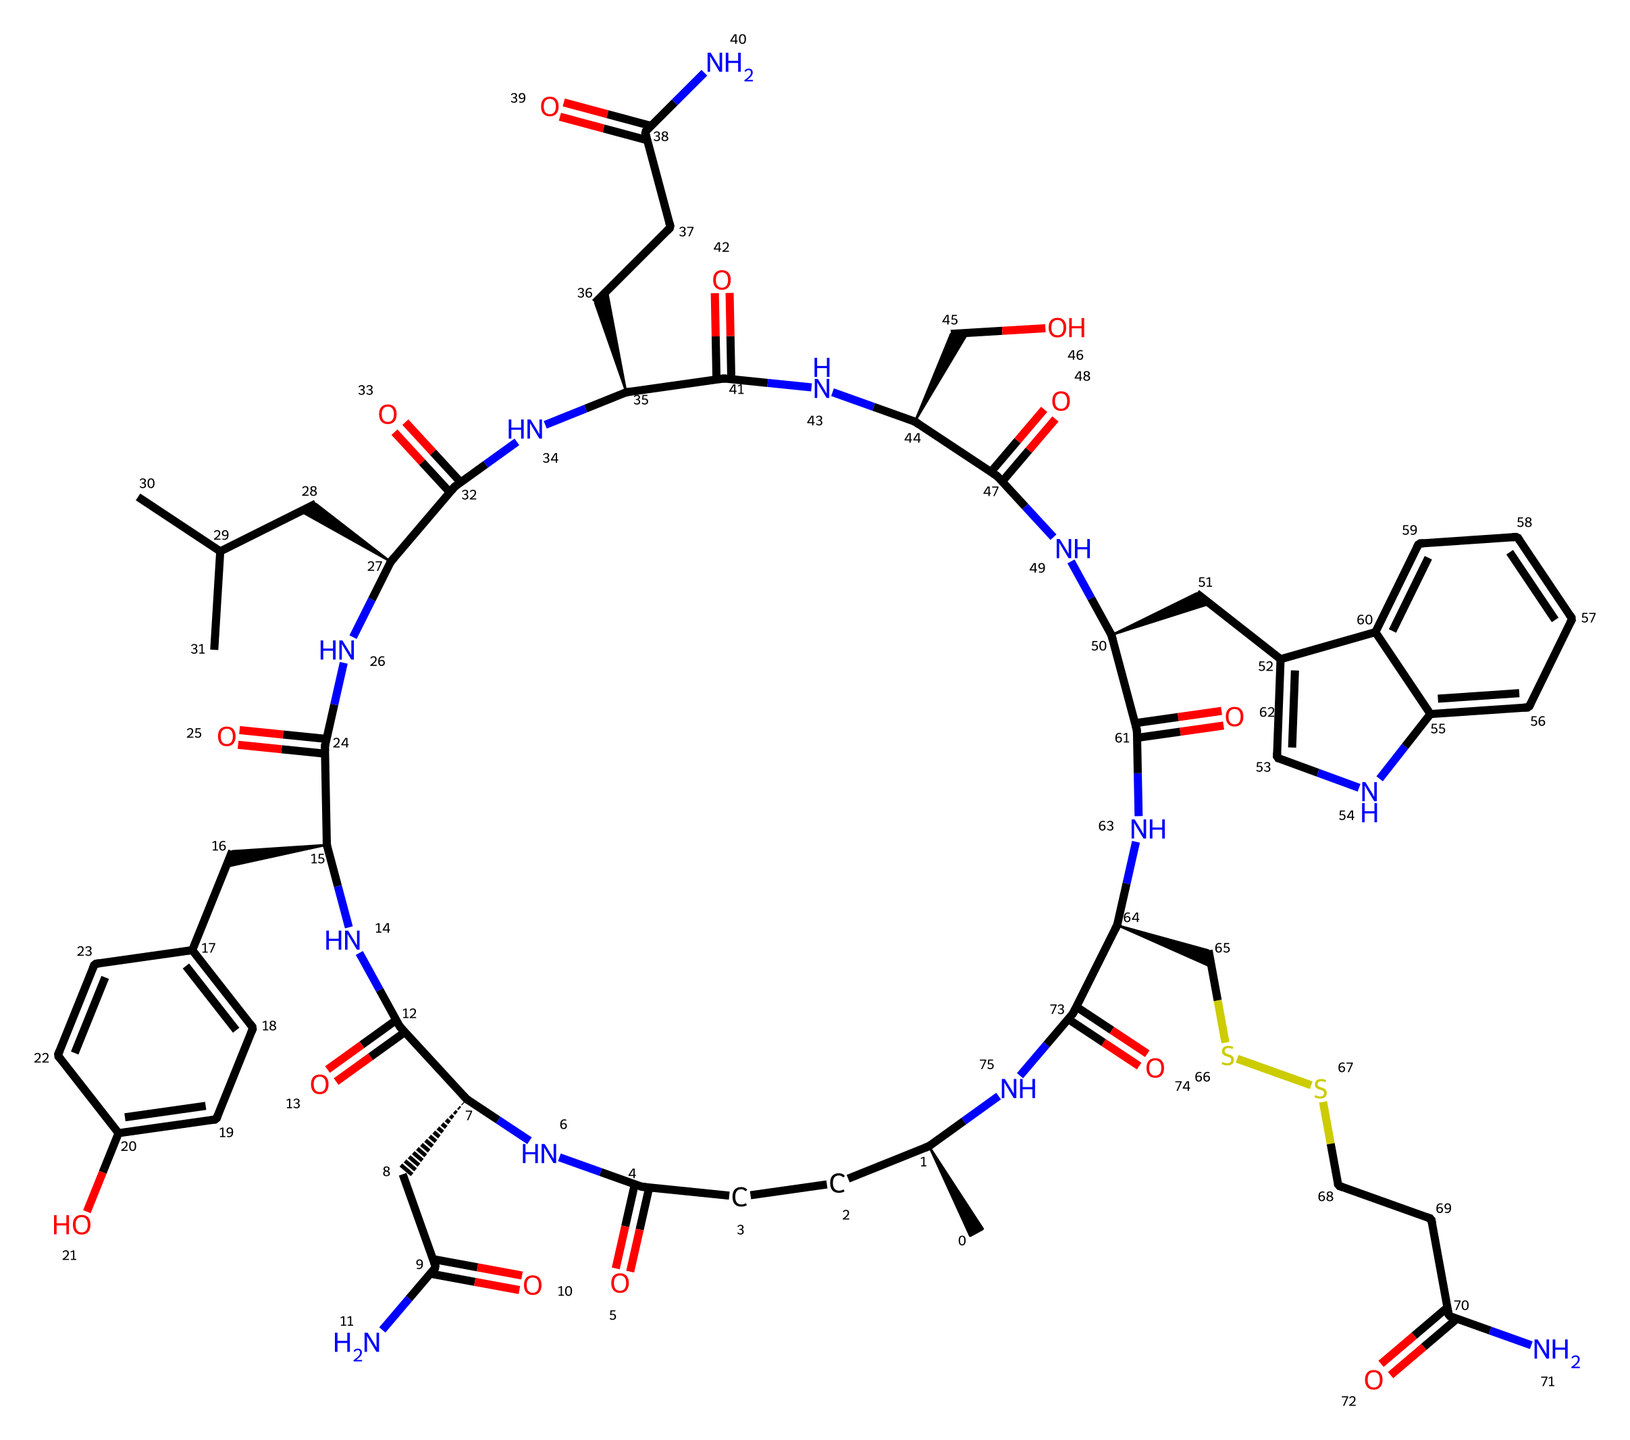What is the name of this hormone? The SMILES representation corresponds to oxytocin, which is a well-known hormone often referred to as the bonding hormone.
Answer: oxytocin How many carbon atoms are in this molecule? Count the number of 'C' atoms in the SMILES string. There are 29 carbon atoms present.
Answer: 29 What type of molecule is oxytocin? Oxytocin is classified as a peptide hormone due to its protein-like structure consisting of amino acids linked by peptide bonds.
Answer: peptide hormone How many nitrogen atoms does this molecule contain? By searching for the 'N' symbols in the SMILES, it's clear that there are 6 nitrogen atoms in the structure.
Answer: 6 Identify one function of oxytocin in the body. Oxytocin is primarily known for facilitating social bonding and attachment as well as childbirth and lactation.
Answer: social bonding Which element is commonly associated with the bonding characteristics of oxytocin? Oxytocin has multiple hydrogen bonds due to the presence of amine groups (-NH) and hydroxyl groups (-OH) that participate in these interactions.
Answer: hydrogen What is the key functional group in oxytocin that enhances its solubility in water? The presence of hydroxyl (-OH) groups and peptide bond (-C(=O)N-) contributes to its water solubility.
Answer: hydroxyl group 